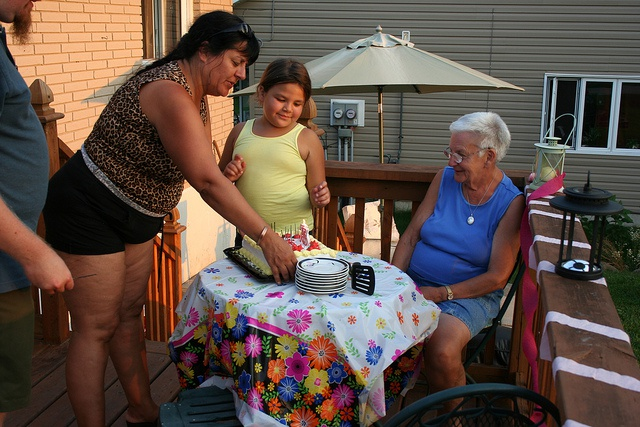Describe the objects in this image and their specific colors. I can see people in brown, black, and maroon tones, people in brown, maroon, blue, navy, and black tones, dining table in brown, lightblue, darkgray, and black tones, people in brown, black, blue, darkblue, and salmon tones, and people in brown, tan, khaki, maroon, and black tones in this image. 